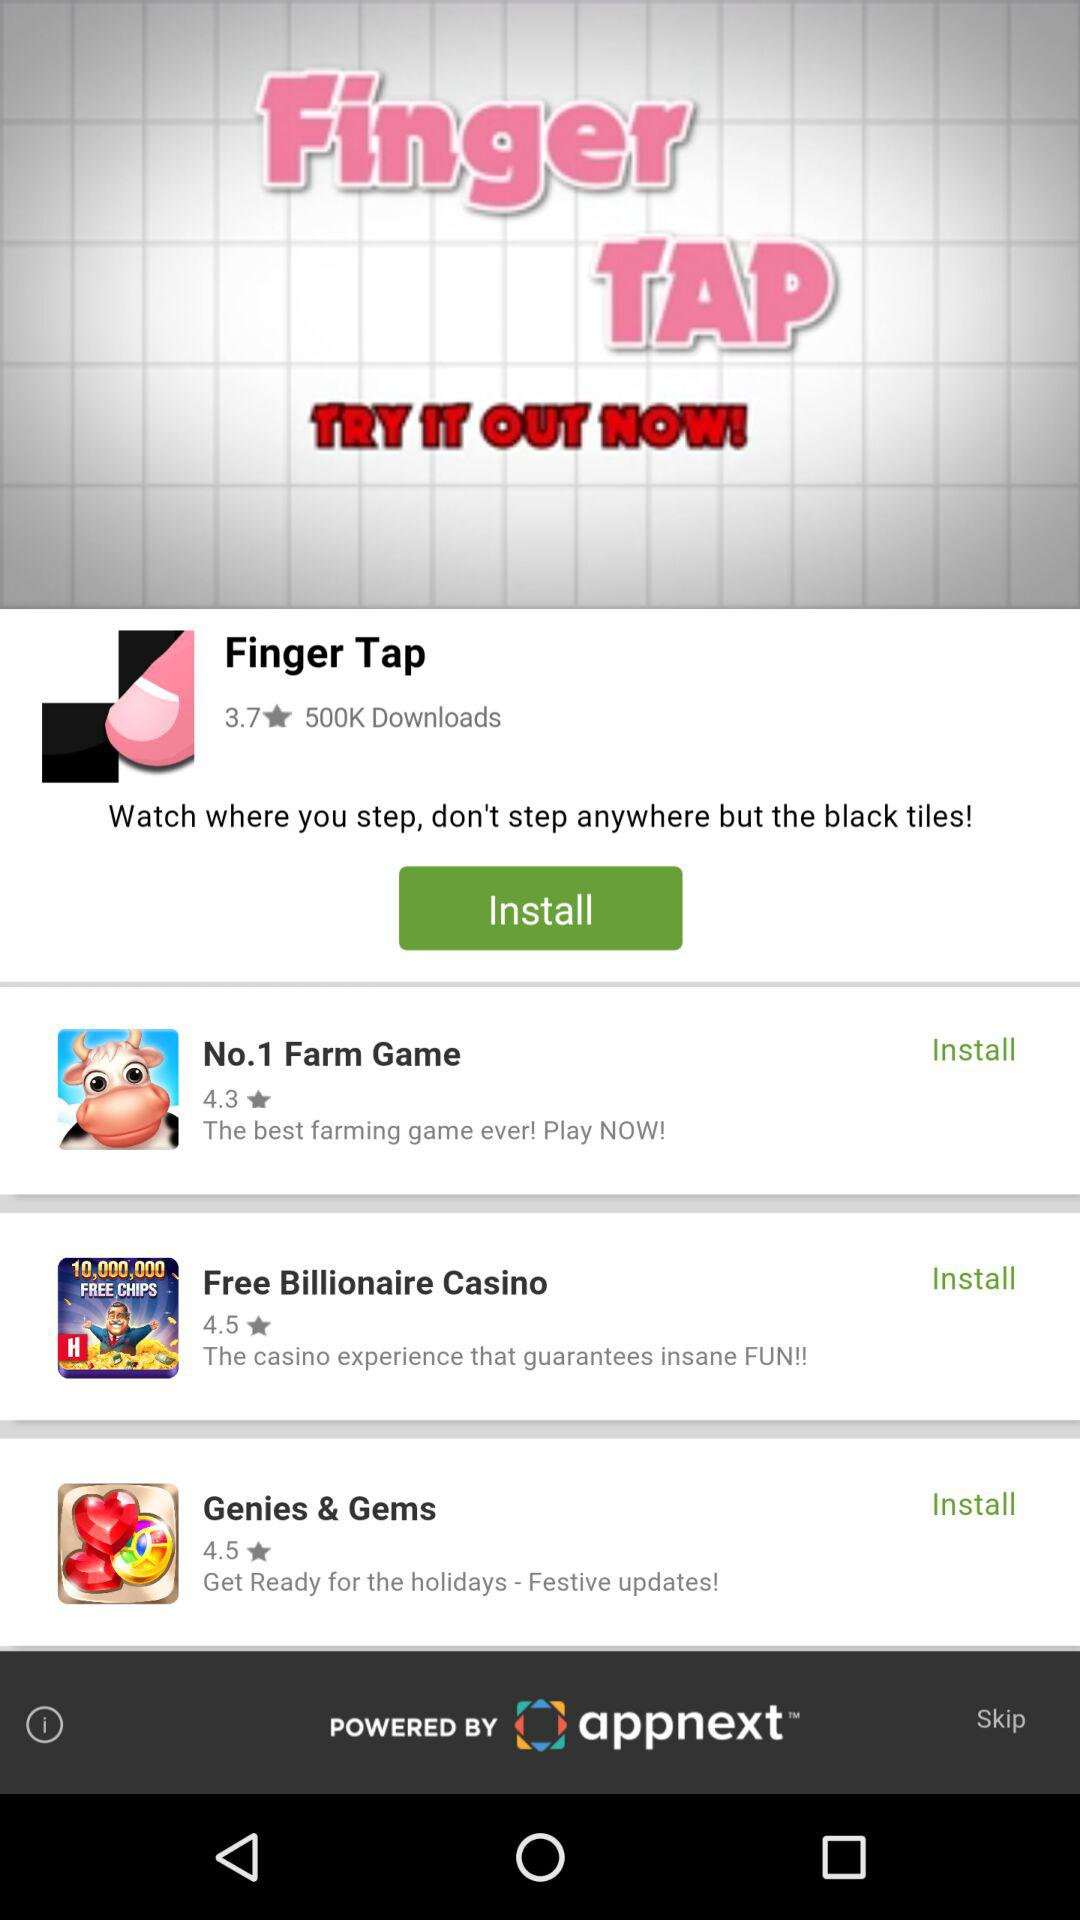How many downloads are there for "Finger Tap"? There are 500K downloads for "Finger Tap". 